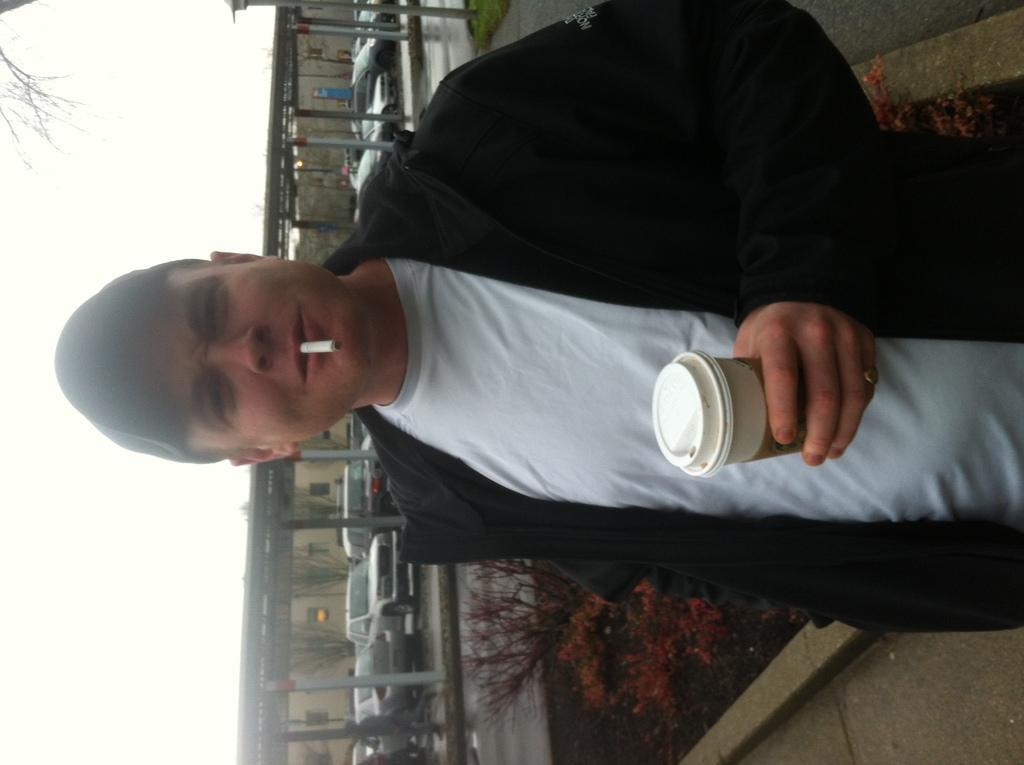Describe this image in one or two sentences. In this image we can see a man is standing, he is wearing white t-shirt and black coat. Holding cup in his hand and cigarette in his mouth. Behind him cars are parked and plants are present. 